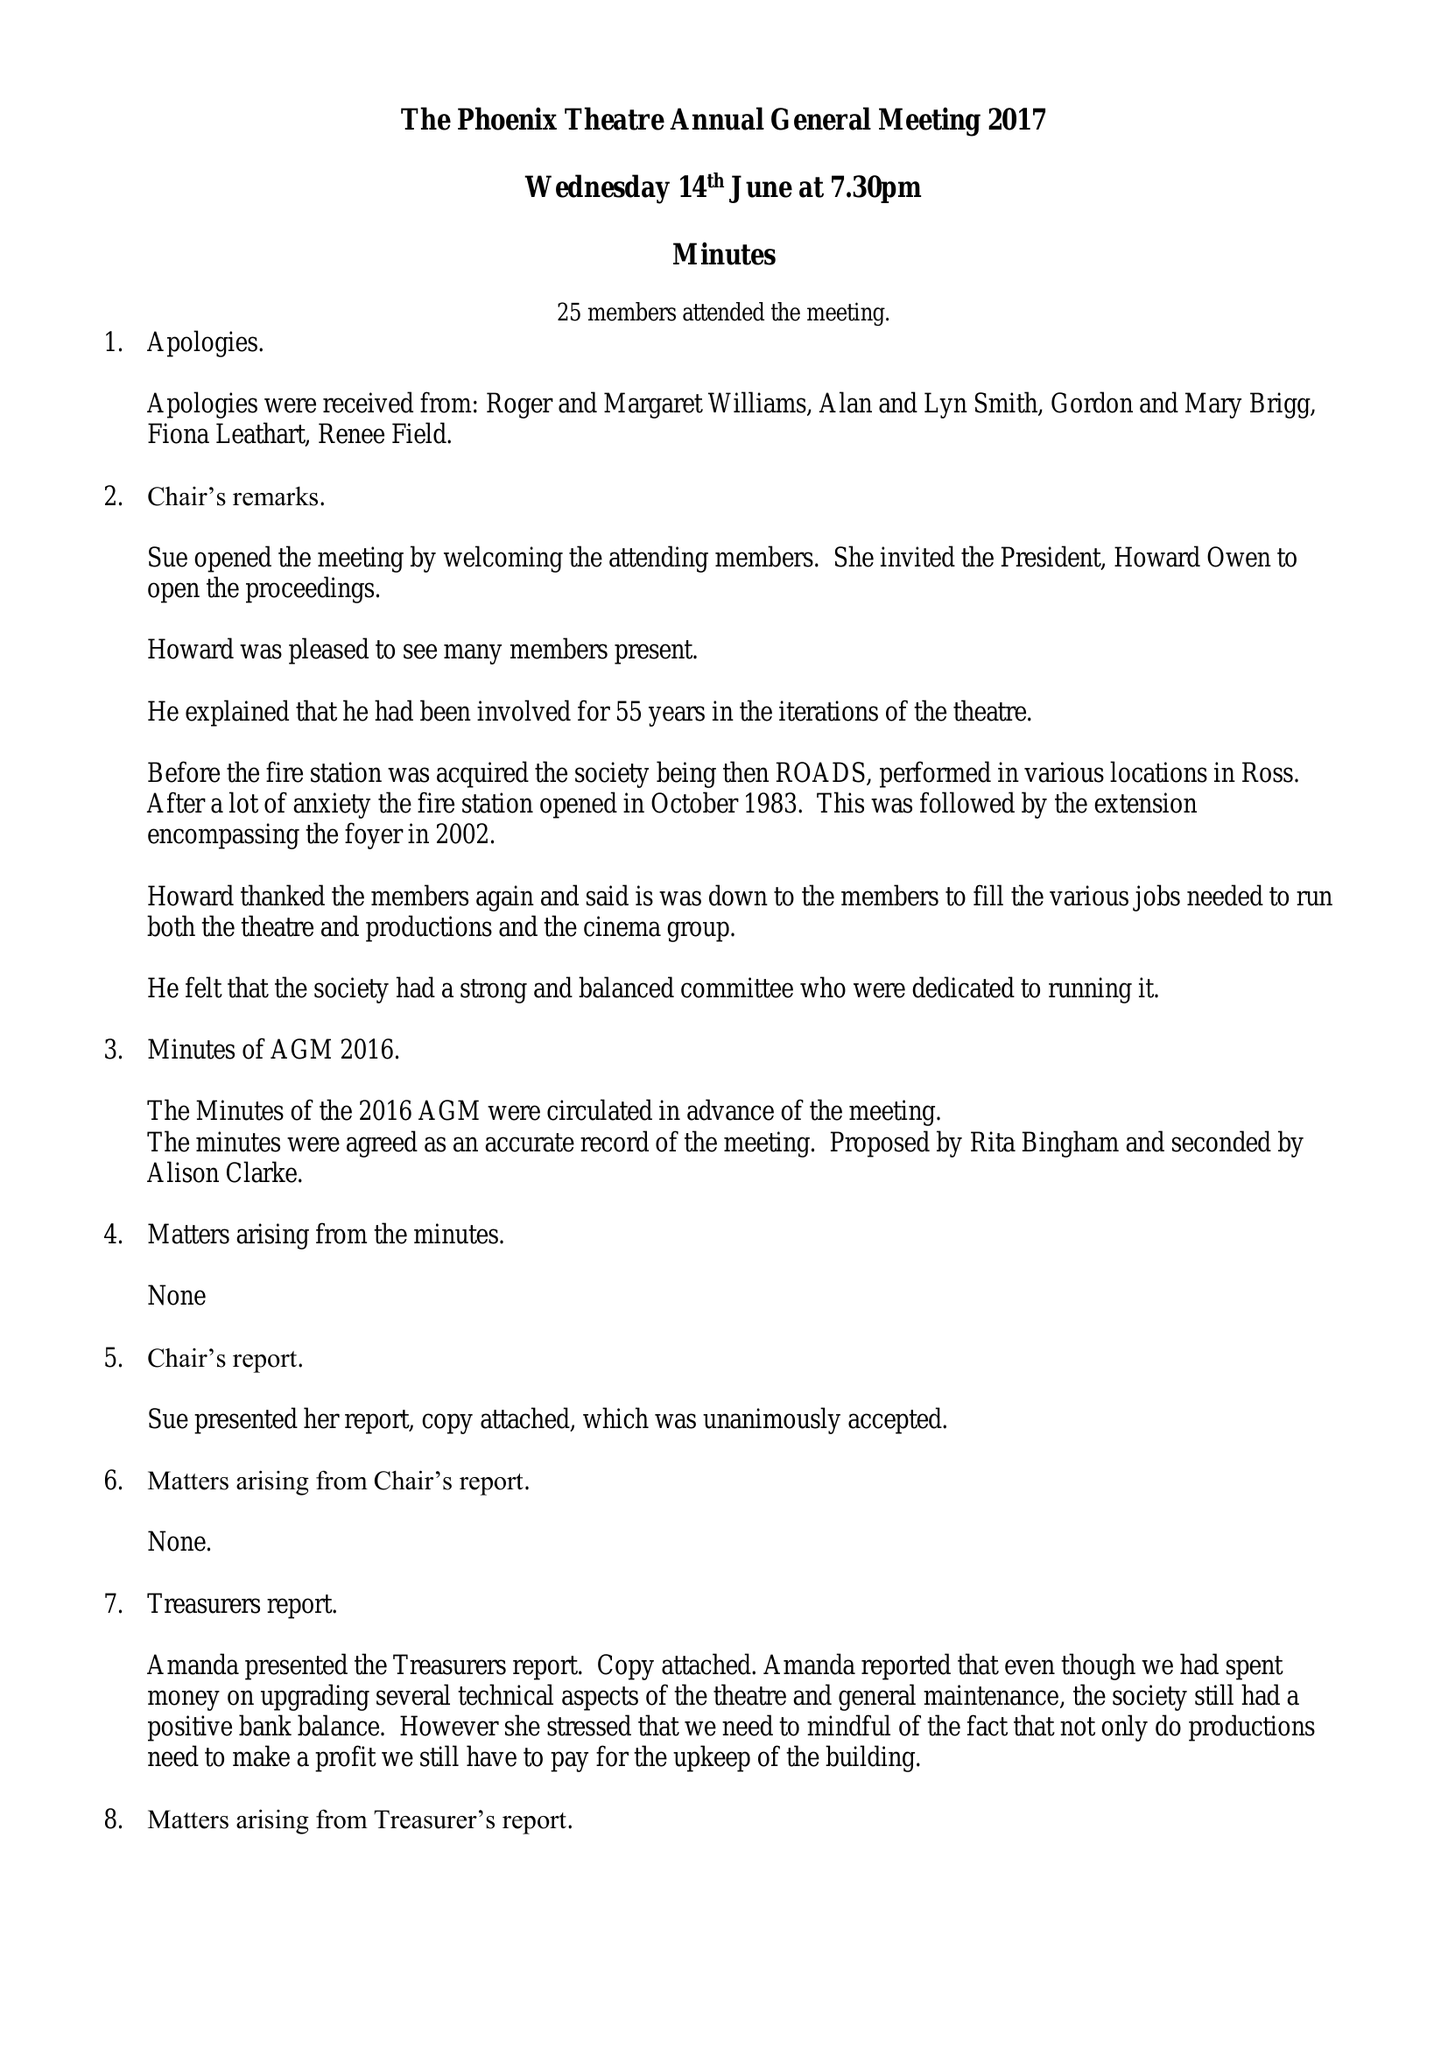What is the value for the charity_name?
Answer the question using a single word or phrase. The Phoenix Theatre Company 